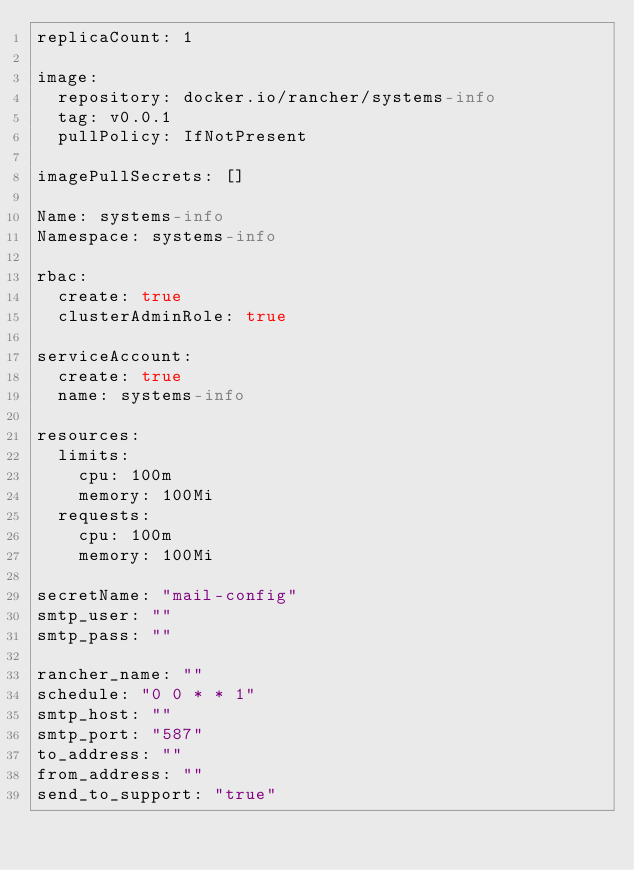<code> <loc_0><loc_0><loc_500><loc_500><_YAML_>replicaCount: 1

image:
  repository: docker.io/rancher/systems-info
  tag: v0.0.1
  pullPolicy: IfNotPresent

imagePullSecrets: []

Name: systems-info
Namespace: systems-info

rbac:
  create: true
  clusterAdminRole: true

serviceAccount:
  create: true
  name: systems-info

resources:
  limits:
    cpu: 100m
    memory: 100Mi
  requests:
    cpu: 100m
    memory: 100Mi

secretName: "mail-config"
smtp_user: ""
smtp_pass: ""

rancher_name: ""
schedule: "0 0 * * 1"
smtp_host: ""
smtp_port: "587"
to_address: ""
from_address: ""
send_to_support: "true"
</code> 